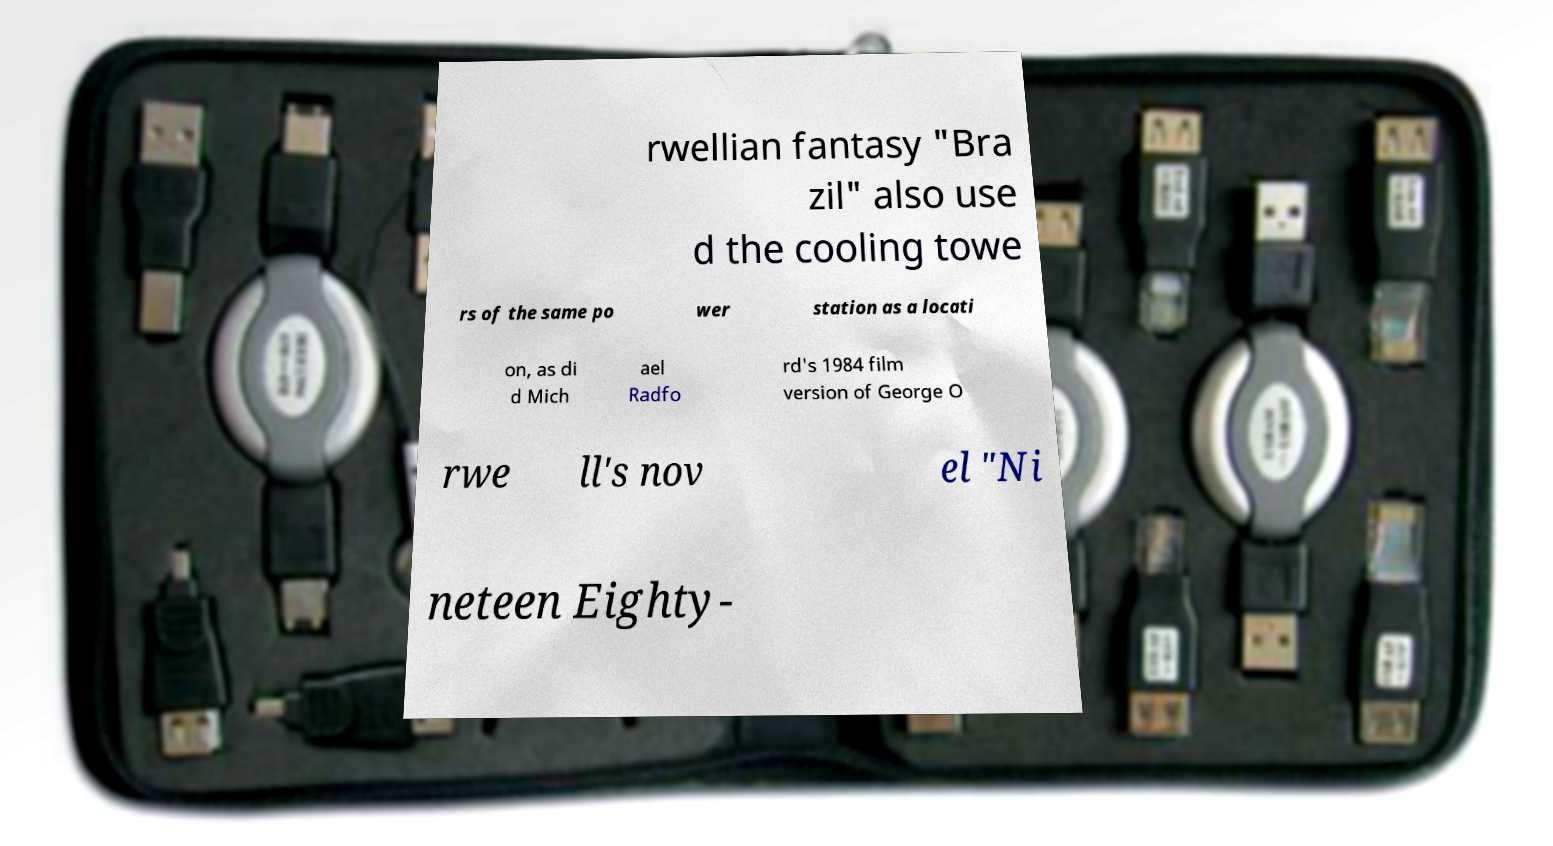Could you assist in decoding the text presented in this image and type it out clearly? rwellian fantasy "Bra zil" also use d the cooling towe rs of the same po wer station as a locati on, as di d Mich ael Radfo rd's 1984 film version of George O rwe ll's nov el "Ni neteen Eighty- 